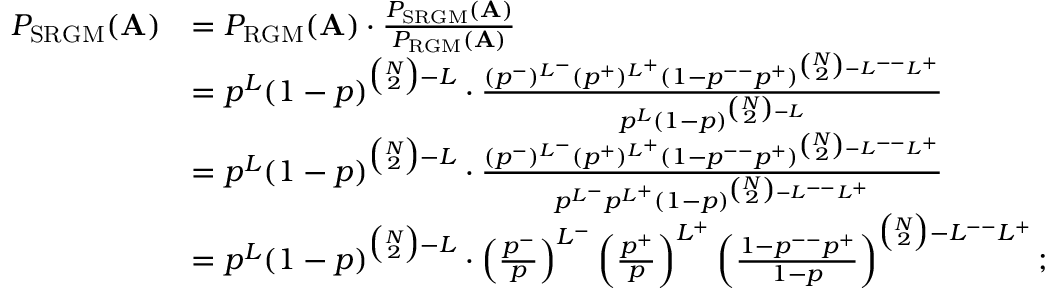Convert formula to latex. <formula><loc_0><loc_0><loc_500><loc_500>\begin{array} { r l } { P _ { S R G M } ( A ) } & { = P _ { R G M } ( A ) \cdot \frac { P _ { S R G M } ( A ) } { P _ { R G M } ( A ) } } \\ & { = p ^ { L } ( 1 - p ) ^ { \binom { N } { 2 } - L } \cdot \frac { ( p ^ { - } ) ^ { L ^ { - } } ( p ^ { + } ) ^ { L ^ { + } } ( 1 - p ^ { - - } p ^ { + } ) ^ { \binom { N } { 2 } - L ^ { - - } L ^ { + } } } { p ^ { L } ( 1 - p ) ^ { \binom { N } { 2 } - L } } } \\ & { = p ^ { L } ( 1 - p ) ^ { \binom { N } { 2 } - L } \cdot \frac { ( p ^ { - } ) ^ { L ^ { - } } ( p ^ { + } ) ^ { L ^ { + } } ( 1 - p ^ { - - } p ^ { + } ) ^ { \binom { N } { 2 } - L ^ { - - } L ^ { + } } } { p ^ { L ^ { - } } p ^ { L ^ { + } } ( 1 - p ) ^ { \binom { N } { 2 } - L ^ { - - } L ^ { + } } } } \\ & { = p ^ { L } ( 1 - p ) ^ { \binom { N } { 2 } - L } \cdot \left ( \frac { p ^ { - } } { p } \right ) ^ { L ^ { - } } \left ( \frac { p ^ { + } } { p } \right ) ^ { L ^ { + } } \left ( \frac { 1 - p ^ { - - } p ^ { + } } { 1 - p } \right ) ^ { \binom { N } { 2 } - L ^ { - - } L ^ { + } } ; } \end{array}</formula> 